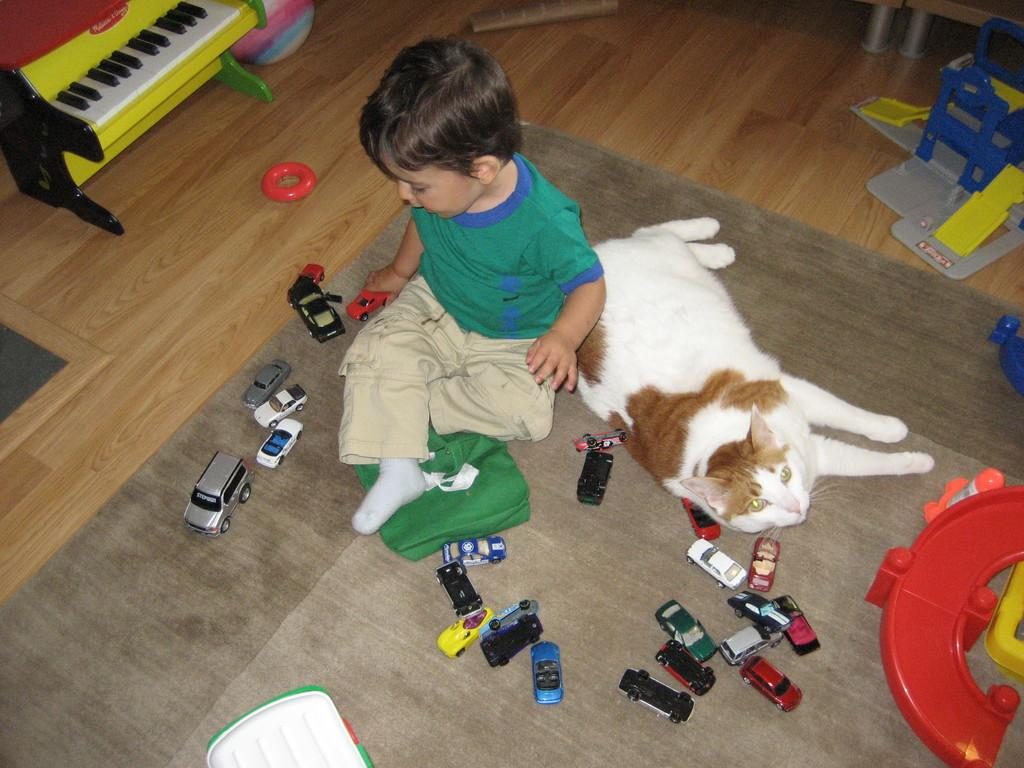Who is present in the image? There is a boy in the image. What is the boy doing in the image? The boy is playing with toys in the image. Are there any animals present in the image? Yes, there is a cat in the image. What is the cat doing in the image? The cat is sleeping beside the boy in the image. What type of dress is the representative wearing in the image? There is no representative present in the image. 